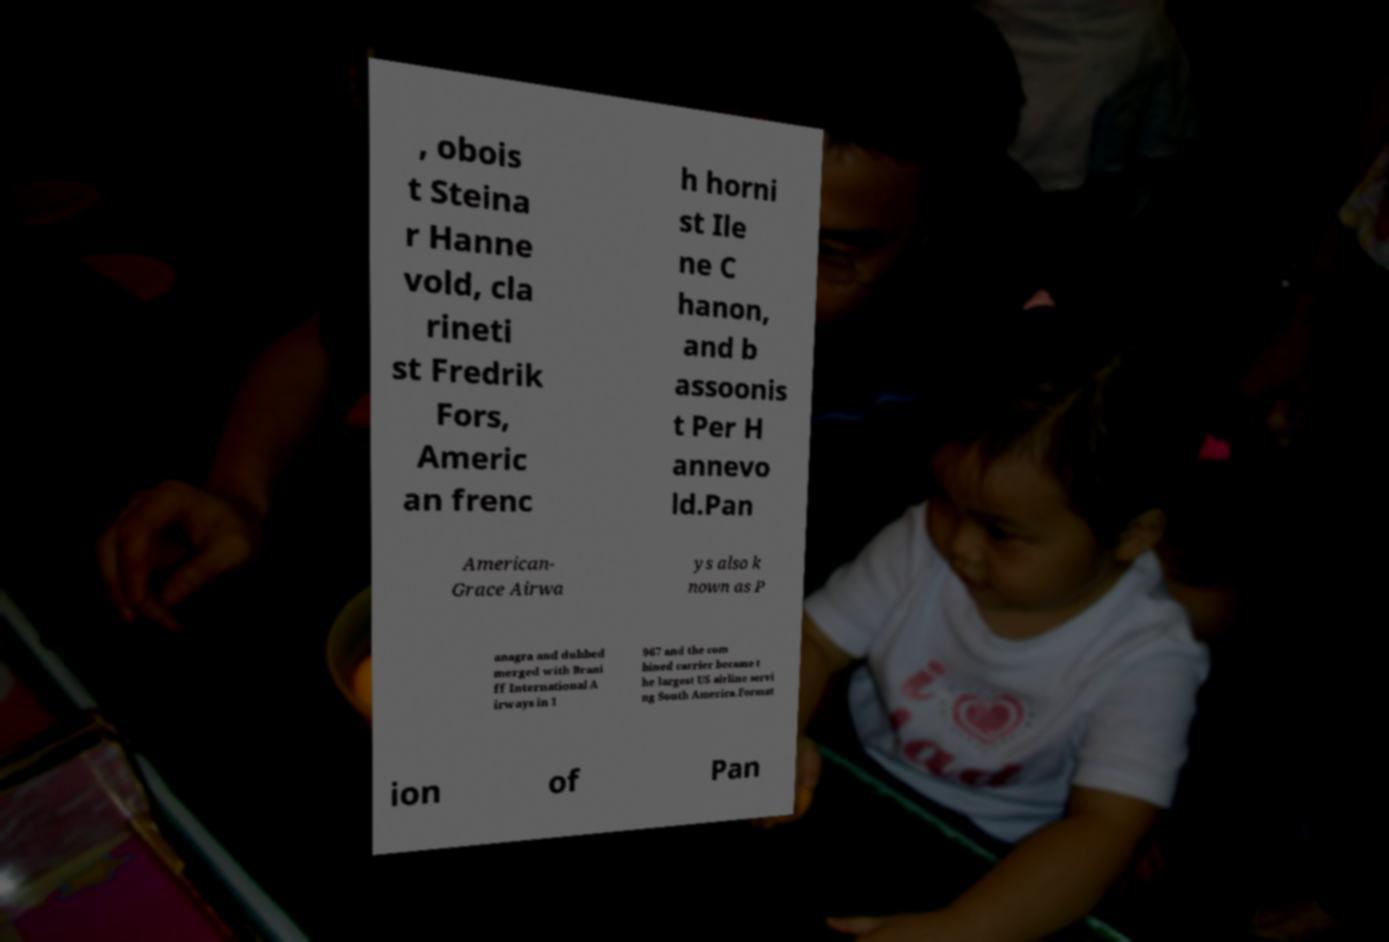Can you read and provide the text displayed in the image?This photo seems to have some interesting text. Can you extract and type it out for me? , obois t Steina r Hanne vold, cla rineti st Fredrik Fors, Americ an frenc h horni st Ile ne C hanon, and b assoonis t Per H annevo ld.Pan American- Grace Airwa ys also k nown as P anagra and dubbed merged with Brani ff International A irways in 1 967 and the com bined carrier became t he largest US airline servi ng South America.Format ion of Pan 